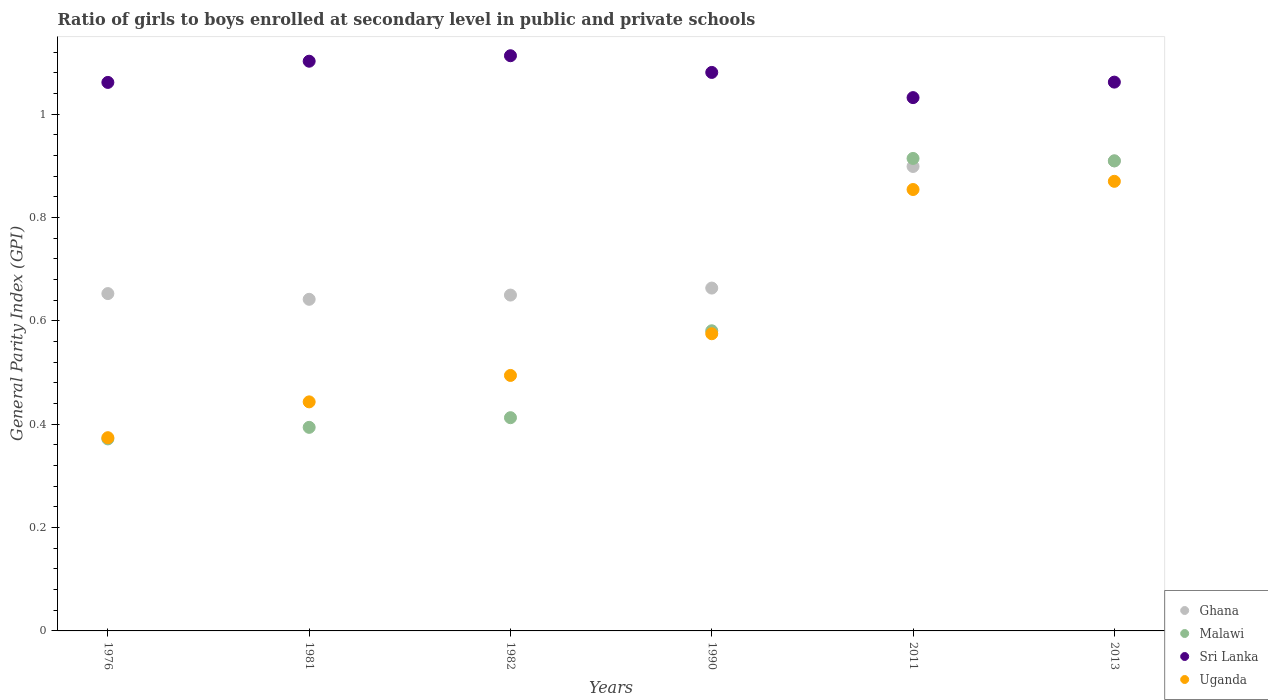How many different coloured dotlines are there?
Offer a terse response. 4. Is the number of dotlines equal to the number of legend labels?
Offer a very short reply. Yes. What is the general parity index in Ghana in 1982?
Provide a succinct answer. 0.65. Across all years, what is the maximum general parity index in Malawi?
Ensure brevity in your answer.  0.91. Across all years, what is the minimum general parity index in Uganda?
Make the answer very short. 0.37. What is the total general parity index in Uganda in the graph?
Your answer should be compact. 3.61. What is the difference between the general parity index in Uganda in 1990 and that in 2013?
Offer a very short reply. -0.3. What is the difference between the general parity index in Malawi in 1981 and the general parity index in Uganda in 1982?
Keep it short and to the point. -0.1. What is the average general parity index in Uganda per year?
Your response must be concise. 0.6. In the year 1982, what is the difference between the general parity index in Sri Lanka and general parity index in Malawi?
Provide a short and direct response. 0.7. What is the ratio of the general parity index in Uganda in 1982 to that in 1990?
Provide a succinct answer. 0.86. Is the difference between the general parity index in Sri Lanka in 1981 and 1990 greater than the difference between the general parity index in Malawi in 1981 and 1990?
Your response must be concise. Yes. What is the difference between the highest and the second highest general parity index in Sri Lanka?
Your answer should be very brief. 0.01. What is the difference between the highest and the lowest general parity index in Ghana?
Ensure brevity in your answer.  0.27. In how many years, is the general parity index in Ghana greater than the average general parity index in Ghana taken over all years?
Ensure brevity in your answer.  2. Is it the case that in every year, the sum of the general parity index in Uganda and general parity index in Ghana  is greater than the sum of general parity index in Malawi and general parity index in Sri Lanka?
Offer a very short reply. Yes. Is the general parity index in Malawi strictly greater than the general parity index in Uganda over the years?
Make the answer very short. No. How many years are there in the graph?
Offer a terse response. 6. Does the graph contain any zero values?
Keep it short and to the point. No. How are the legend labels stacked?
Offer a very short reply. Vertical. What is the title of the graph?
Make the answer very short. Ratio of girls to boys enrolled at secondary level in public and private schools. What is the label or title of the Y-axis?
Offer a very short reply. General Parity Index (GPI). What is the General Parity Index (GPI) of Ghana in 1976?
Your response must be concise. 0.65. What is the General Parity Index (GPI) in Malawi in 1976?
Keep it short and to the point. 0.37. What is the General Parity Index (GPI) of Sri Lanka in 1976?
Offer a terse response. 1.06. What is the General Parity Index (GPI) of Uganda in 1976?
Provide a short and direct response. 0.37. What is the General Parity Index (GPI) in Ghana in 1981?
Your response must be concise. 0.64. What is the General Parity Index (GPI) in Malawi in 1981?
Ensure brevity in your answer.  0.39. What is the General Parity Index (GPI) of Sri Lanka in 1981?
Offer a terse response. 1.1. What is the General Parity Index (GPI) of Uganda in 1981?
Provide a short and direct response. 0.44. What is the General Parity Index (GPI) in Ghana in 1982?
Offer a terse response. 0.65. What is the General Parity Index (GPI) of Malawi in 1982?
Your answer should be very brief. 0.41. What is the General Parity Index (GPI) in Sri Lanka in 1982?
Your answer should be compact. 1.11. What is the General Parity Index (GPI) in Uganda in 1982?
Provide a short and direct response. 0.49. What is the General Parity Index (GPI) of Ghana in 1990?
Provide a short and direct response. 0.66. What is the General Parity Index (GPI) of Malawi in 1990?
Offer a terse response. 0.58. What is the General Parity Index (GPI) of Sri Lanka in 1990?
Your response must be concise. 1.08. What is the General Parity Index (GPI) in Uganda in 1990?
Give a very brief answer. 0.58. What is the General Parity Index (GPI) in Ghana in 2011?
Ensure brevity in your answer.  0.9. What is the General Parity Index (GPI) of Malawi in 2011?
Provide a short and direct response. 0.91. What is the General Parity Index (GPI) in Sri Lanka in 2011?
Ensure brevity in your answer.  1.03. What is the General Parity Index (GPI) of Uganda in 2011?
Your answer should be very brief. 0.85. What is the General Parity Index (GPI) in Ghana in 2013?
Your answer should be compact. 0.91. What is the General Parity Index (GPI) of Malawi in 2013?
Your answer should be compact. 0.91. What is the General Parity Index (GPI) in Sri Lanka in 2013?
Your answer should be compact. 1.06. What is the General Parity Index (GPI) of Uganda in 2013?
Keep it short and to the point. 0.87. Across all years, what is the maximum General Parity Index (GPI) in Ghana?
Offer a terse response. 0.91. Across all years, what is the maximum General Parity Index (GPI) of Malawi?
Your answer should be very brief. 0.91. Across all years, what is the maximum General Parity Index (GPI) in Sri Lanka?
Your answer should be very brief. 1.11. Across all years, what is the maximum General Parity Index (GPI) of Uganda?
Your answer should be very brief. 0.87. Across all years, what is the minimum General Parity Index (GPI) in Ghana?
Provide a short and direct response. 0.64. Across all years, what is the minimum General Parity Index (GPI) of Malawi?
Keep it short and to the point. 0.37. Across all years, what is the minimum General Parity Index (GPI) of Sri Lanka?
Ensure brevity in your answer.  1.03. Across all years, what is the minimum General Parity Index (GPI) in Uganda?
Give a very brief answer. 0.37. What is the total General Parity Index (GPI) in Ghana in the graph?
Your answer should be very brief. 4.42. What is the total General Parity Index (GPI) in Malawi in the graph?
Your answer should be very brief. 3.58. What is the total General Parity Index (GPI) in Sri Lanka in the graph?
Provide a succinct answer. 6.45. What is the total General Parity Index (GPI) in Uganda in the graph?
Your answer should be very brief. 3.61. What is the difference between the General Parity Index (GPI) of Ghana in 1976 and that in 1981?
Your answer should be very brief. 0.01. What is the difference between the General Parity Index (GPI) of Malawi in 1976 and that in 1981?
Provide a short and direct response. -0.02. What is the difference between the General Parity Index (GPI) in Sri Lanka in 1976 and that in 1981?
Offer a very short reply. -0.04. What is the difference between the General Parity Index (GPI) in Uganda in 1976 and that in 1981?
Ensure brevity in your answer.  -0.07. What is the difference between the General Parity Index (GPI) in Ghana in 1976 and that in 1982?
Give a very brief answer. 0. What is the difference between the General Parity Index (GPI) of Malawi in 1976 and that in 1982?
Offer a very short reply. -0.04. What is the difference between the General Parity Index (GPI) in Sri Lanka in 1976 and that in 1982?
Keep it short and to the point. -0.05. What is the difference between the General Parity Index (GPI) of Uganda in 1976 and that in 1982?
Offer a terse response. -0.12. What is the difference between the General Parity Index (GPI) of Ghana in 1976 and that in 1990?
Offer a very short reply. -0.01. What is the difference between the General Parity Index (GPI) of Malawi in 1976 and that in 1990?
Give a very brief answer. -0.21. What is the difference between the General Parity Index (GPI) of Sri Lanka in 1976 and that in 1990?
Provide a short and direct response. -0.02. What is the difference between the General Parity Index (GPI) in Uganda in 1976 and that in 1990?
Your answer should be compact. -0.2. What is the difference between the General Parity Index (GPI) in Ghana in 1976 and that in 2011?
Offer a very short reply. -0.25. What is the difference between the General Parity Index (GPI) of Malawi in 1976 and that in 2011?
Make the answer very short. -0.54. What is the difference between the General Parity Index (GPI) in Sri Lanka in 1976 and that in 2011?
Keep it short and to the point. 0.03. What is the difference between the General Parity Index (GPI) of Uganda in 1976 and that in 2011?
Your response must be concise. -0.48. What is the difference between the General Parity Index (GPI) in Ghana in 1976 and that in 2013?
Provide a succinct answer. -0.26. What is the difference between the General Parity Index (GPI) of Malawi in 1976 and that in 2013?
Make the answer very short. -0.54. What is the difference between the General Parity Index (GPI) in Sri Lanka in 1976 and that in 2013?
Give a very brief answer. -0. What is the difference between the General Parity Index (GPI) of Uganda in 1976 and that in 2013?
Your response must be concise. -0.5. What is the difference between the General Parity Index (GPI) of Ghana in 1981 and that in 1982?
Offer a very short reply. -0.01. What is the difference between the General Parity Index (GPI) of Malawi in 1981 and that in 1982?
Make the answer very short. -0.02. What is the difference between the General Parity Index (GPI) in Sri Lanka in 1981 and that in 1982?
Keep it short and to the point. -0.01. What is the difference between the General Parity Index (GPI) in Uganda in 1981 and that in 1982?
Your answer should be very brief. -0.05. What is the difference between the General Parity Index (GPI) in Ghana in 1981 and that in 1990?
Provide a short and direct response. -0.02. What is the difference between the General Parity Index (GPI) of Malawi in 1981 and that in 1990?
Ensure brevity in your answer.  -0.19. What is the difference between the General Parity Index (GPI) of Sri Lanka in 1981 and that in 1990?
Your response must be concise. 0.02. What is the difference between the General Parity Index (GPI) in Uganda in 1981 and that in 1990?
Offer a terse response. -0.13. What is the difference between the General Parity Index (GPI) in Ghana in 1981 and that in 2011?
Offer a terse response. -0.26. What is the difference between the General Parity Index (GPI) of Malawi in 1981 and that in 2011?
Give a very brief answer. -0.52. What is the difference between the General Parity Index (GPI) of Sri Lanka in 1981 and that in 2011?
Offer a terse response. 0.07. What is the difference between the General Parity Index (GPI) of Uganda in 1981 and that in 2011?
Ensure brevity in your answer.  -0.41. What is the difference between the General Parity Index (GPI) in Ghana in 1981 and that in 2013?
Ensure brevity in your answer.  -0.27. What is the difference between the General Parity Index (GPI) in Malawi in 1981 and that in 2013?
Give a very brief answer. -0.52. What is the difference between the General Parity Index (GPI) of Sri Lanka in 1981 and that in 2013?
Make the answer very short. 0.04. What is the difference between the General Parity Index (GPI) of Uganda in 1981 and that in 2013?
Your response must be concise. -0.43. What is the difference between the General Parity Index (GPI) in Ghana in 1982 and that in 1990?
Offer a terse response. -0.01. What is the difference between the General Parity Index (GPI) in Malawi in 1982 and that in 1990?
Your answer should be compact. -0.17. What is the difference between the General Parity Index (GPI) in Sri Lanka in 1982 and that in 1990?
Offer a very short reply. 0.03. What is the difference between the General Parity Index (GPI) of Uganda in 1982 and that in 1990?
Provide a short and direct response. -0.08. What is the difference between the General Parity Index (GPI) of Ghana in 1982 and that in 2011?
Your response must be concise. -0.25. What is the difference between the General Parity Index (GPI) of Malawi in 1982 and that in 2011?
Ensure brevity in your answer.  -0.5. What is the difference between the General Parity Index (GPI) in Sri Lanka in 1982 and that in 2011?
Make the answer very short. 0.08. What is the difference between the General Parity Index (GPI) in Uganda in 1982 and that in 2011?
Your answer should be compact. -0.36. What is the difference between the General Parity Index (GPI) in Ghana in 1982 and that in 2013?
Your answer should be very brief. -0.26. What is the difference between the General Parity Index (GPI) of Malawi in 1982 and that in 2013?
Offer a terse response. -0.5. What is the difference between the General Parity Index (GPI) of Sri Lanka in 1982 and that in 2013?
Your answer should be compact. 0.05. What is the difference between the General Parity Index (GPI) of Uganda in 1982 and that in 2013?
Your answer should be very brief. -0.38. What is the difference between the General Parity Index (GPI) in Ghana in 1990 and that in 2011?
Your response must be concise. -0.24. What is the difference between the General Parity Index (GPI) in Malawi in 1990 and that in 2011?
Offer a very short reply. -0.33. What is the difference between the General Parity Index (GPI) in Sri Lanka in 1990 and that in 2011?
Provide a succinct answer. 0.05. What is the difference between the General Parity Index (GPI) of Uganda in 1990 and that in 2011?
Offer a terse response. -0.28. What is the difference between the General Parity Index (GPI) of Ghana in 1990 and that in 2013?
Offer a terse response. -0.25. What is the difference between the General Parity Index (GPI) in Malawi in 1990 and that in 2013?
Your answer should be compact. -0.33. What is the difference between the General Parity Index (GPI) of Sri Lanka in 1990 and that in 2013?
Keep it short and to the point. 0.02. What is the difference between the General Parity Index (GPI) of Uganda in 1990 and that in 2013?
Ensure brevity in your answer.  -0.29. What is the difference between the General Parity Index (GPI) in Ghana in 2011 and that in 2013?
Provide a succinct answer. -0.01. What is the difference between the General Parity Index (GPI) in Malawi in 2011 and that in 2013?
Your answer should be very brief. 0. What is the difference between the General Parity Index (GPI) of Sri Lanka in 2011 and that in 2013?
Offer a terse response. -0.03. What is the difference between the General Parity Index (GPI) of Uganda in 2011 and that in 2013?
Provide a short and direct response. -0.02. What is the difference between the General Parity Index (GPI) in Ghana in 1976 and the General Parity Index (GPI) in Malawi in 1981?
Provide a succinct answer. 0.26. What is the difference between the General Parity Index (GPI) in Ghana in 1976 and the General Parity Index (GPI) in Sri Lanka in 1981?
Your response must be concise. -0.45. What is the difference between the General Parity Index (GPI) of Ghana in 1976 and the General Parity Index (GPI) of Uganda in 1981?
Give a very brief answer. 0.21. What is the difference between the General Parity Index (GPI) in Malawi in 1976 and the General Parity Index (GPI) in Sri Lanka in 1981?
Your answer should be very brief. -0.73. What is the difference between the General Parity Index (GPI) in Malawi in 1976 and the General Parity Index (GPI) in Uganda in 1981?
Your answer should be very brief. -0.07. What is the difference between the General Parity Index (GPI) of Sri Lanka in 1976 and the General Parity Index (GPI) of Uganda in 1981?
Your answer should be compact. 0.62. What is the difference between the General Parity Index (GPI) in Ghana in 1976 and the General Parity Index (GPI) in Malawi in 1982?
Offer a terse response. 0.24. What is the difference between the General Parity Index (GPI) of Ghana in 1976 and the General Parity Index (GPI) of Sri Lanka in 1982?
Make the answer very short. -0.46. What is the difference between the General Parity Index (GPI) of Ghana in 1976 and the General Parity Index (GPI) of Uganda in 1982?
Provide a short and direct response. 0.16. What is the difference between the General Parity Index (GPI) of Malawi in 1976 and the General Parity Index (GPI) of Sri Lanka in 1982?
Your answer should be compact. -0.74. What is the difference between the General Parity Index (GPI) in Malawi in 1976 and the General Parity Index (GPI) in Uganda in 1982?
Your response must be concise. -0.12. What is the difference between the General Parity Index (GPI) of Sri Lanka in 1976 and the General Parity Index (GPI) of Uganda in 1982?
Your answer should be very brief. 0.57. What is the difference between the General Parity Index (GPI) of Ghana in 1976 and the General Parity Index (GPI) of Malawi in 1990?
Keep it short and to the point. 0.07. What is the difference between the General Parity Index (GPI) of Ghana in 1976 and the General Parity Index (GPI) of Sri Lanka in 1990?
Give a very brief answer. -0.43. What is the difference between the General Parity Index (GPI) in Ghana in 1976 and the General Parity Index (GPI) in Uganda in 1990?
Provide a succinct answer. 0.08. What is the difference between the General Parity Index (GPI) in Malawi in 1976 and the General Parity Index (GPI) in Sri Lanka in 1990?
Keep it short and to the point. -0.71. What is the difference between the General Parity Index (GPI) in Malawi in 1976 and the General Parity Index (GPI) in Uganda in 1990?
Your response must be concise. -0.2. What is the difference between the General Parity Index (GPI) of Sri Lanka in 1976 and the General Parity Index (GPI) of Uganda in 1990?
Make the answer very short. 0.49. What is the difference between the General Parity Index (GPI) in Ghana in 1976 and the General Parity Index (GPI) in Malawi in 2011?
Make the answer very short. -0.26. What is the difference between the General Parity Index (GPI) in Ghana in 1976 and the General Parity Index (GPI) in Sri Lanka in 2011?
Offer a terse response. -0.38. What is the difference between the General Parity Index (GPI) of Ghana in 1976 and the General Parity Index (GPI) of Uganda in 2011?
Keep it short and to the point. -0.2. What is the difference between the General Parity Index (GPI) of Malawi in 1976 and the General Parity Index (GPI) of Sri Lanka in 2011?
Your answer should be very brief. -0.66. What is the difference between the General Parity Index (GPI) in Malawi in 1976 and the General Parity Index (GPI) in Uganda in 2011?
Your answer should be very brief. -0.48. What is the difference between the General Parity Index (GPI) in Sri Lanka in 1976 and the General Parity Index (GPI) in Uganda in 2011?
Provide a short and direct response. 0.21. What is the difference between the General Parity Index (GPI) in Ghana in 1976 and the General Parity Index (GPI) in Malawi in 2013?
Offer a terse response. -0.26. What is the difference between the General Parity Index (GPI) of Ghana in 1976 and the General Parity Index (GPI) of Sri Lanka in 2013?
Ensure brevity in your answer.  -0.41. What is the difference between the General Parity Index (GPI) of Ghana in 1976 and the General Parity Index (GPI) of Uganda in 2013?
Give a very brief answer. -0.22. What is the difference between the General Parity Index (GPI) in Malawi in 1976 and the General Parity Index (GPI) in Sri Lanka in 2013?
Provide a succinct answer. -0.69. What is the difference between the General Parity Index (GPI) of Malawi in 1976 and the General Parity Index (GPI) of Uganda in 2013?
Your response must be concise. -0.5. What is the difference between the General Parity Index (GPI) in Sri Lanka in 1976 and the General Parity Index (GPI) in Uganda in 2013?
Offer a very short reply. 0.19. What is the difference between the General Parity Index (GPI) of Ghana in 1981 and the General Parity Index (GPI) of Malawi in 1982?
Make the answer very short. 0.23. What is the difference between the General Parity Index (GPI) in Ghana in 1981 and the General Parity Index (GPI) in Sri Lanka in 1982?
Make the answer very short. -0.47. What is the difference between the General Parity Index (GPI) in Ghana in 1981 and the General Parity Index (GPI) in Uganda in 1982?
Offer a terse response. 0.15. What is the difference between the General Parity Index (GPI) in Malawi in 1981 and the General Parity Index (GPI) in Sri Lanka in 1982?
Provide a short and direct response. -0.72. What is the difference between the General Parity Index (GPI) of Malawi in 1981 and the General Parity Index (GPI) of Uganda in 1982?
Your answer should be compact. -0.1. What is the difference between the General Parity Index (GPI) of Sri Lanka in 1981 and the General Parity Index (GPI) of Uganda in 1982?
Make the answer very short. 0.61. What is the difference between the General Parity Index (GPI) in Ghana in 1981 and the General Parity Index (GPI) in Malawi in 1990?
Keep it short and to the point. 0.06. What is the difference between the General Parity Index (GPI) in Ghana in 1981 and the General Parity Index (GPI) in Sri Lanka in 1990?
Ensure brevity in your answer.  -0.44. What is the difference between the General Parity Index (GPI) in Ghana in 1981 and the General Parity Index (GPI) in Uganda in 1990?
Provide a short and direct response. 0.07. What is the difference between the General Parity Index (GPI) of Malawi in 1981 and the General Parity Index (GPI) of Sri Lanka in 1990?
Your answer should be very brief. -0.69. What is the difference between the General Parity Index (GPI) in Malawi in 1981 and the General Parity Index (GPI) in Uganda in 1990?
Give a very brief answer. -0.18. What is the difference between the General Parity Index (GPI) in Sri Lanka in 1981 and the General Parity Index (GPI) in Uganda in 1990?
Your response must be concise. 0.53. What is the difference between the General Parity Index (GPI) of Ghana in 1981 and the General Parity Index (GPI) of Malawi in 2011?
Your answer should be very brief. -0.27. What is the difference between the General Parity Index (GPI) of Ghana in 1981 and the General Parity Index (GPI) of Sri Lanka in 2011?
Offer a very short reply. -0.39. What is the difference between the General Parity Index (GPI) in Ghana in 1981 and the General Parity Index (GPI) in Uganda in 2011?
Keep it short and to the point. -0.21. What is the difference between the General Parity Index (GPI) of Malawi in 1981 and the General Parity Index (GPI) of Sri Lanka in 2011?
Ensure brevity in your answer.  -0.64. What is the difference between the General Parity Index (GPI) in Malawi in 1981 and the General Parity Index (GPI) in Uganda in 2011?
Give a very brief answer. -0.46. What is the difference between the General Parity Index (GPI) in Sri Lanka in 1981 and the General Parity Index (GPI) in Uganda in 2011?
Give a very brief answer. 0.25. What is the difference between the General Parity Index (GPI) in Ghana in 1981 and the General Parity Index (GPI) in Malawi in 2013?
Make the answer very short. -0.27. What is the difference between the General Parity Index (GPI) of Ghana in 1981 and the General Parity Index (GPI) of Sri Lanka in 2013?
Your answer should be very brief. -0.42. What is the difference between the General Parity Index (GPI) in Ghana in 1981 and the General Parity Index (GPI) in Uganda in 2013?
Your answer should be very brief. -0.23. What is the difference between the General Parity Index (GPI) in Malawi in 1981 and the General Parity Index (GPI) in Sri Lanka in 2013?
Give a very brief answer. -0.67. What is the difference between the General Parity Index (GPI) of Malawi in 1981 and the General Parity Index (GPI) of Uganda in 2013?
Provide a succinct answer. -0.48. What is the difference between the General Parity Index (GPI) of Sri Lanka in 1981 and the General Parity Index (GPI) of Uganda in 2013?
Make the answer very short. 0.23. What is the difference between the General Parity Index (GPI) of Ghana in 1982 and the General Parity Index (GPI) of Malawi in 1990?
Give a very brief answer. 0.07. What is the difference between the General Parity Index (GPI) of Ghana in 1982 and the General Parity Index (GPI) of Sri Lanka in 1990?
Your answer should be compact. -0.43. What is the difference between the General Parity Index (GPI) in Ghana in 1982 and the General Parity Index (GPI) in Uganda in 1990?
Make the answer very short. 0.07. What is the difference between the General Parity Index (GPI) of Malawi in 1982 and the General Parity Index (GPI) of Sri Lanka in 1990?
Provide a succinct answer. -0.67. What is the difference between the General Parity Index (GPI) of Malawi in 1982 and the General Parity Index (GPI) of Uganda in 1990?
Make the answer very short. -0.16. What is the difference between the General Parity Index (GPI) of Sri Lanka in 1982 and the General Parity Index (GPI) of Uganda in 1990?
Your response must be concise. 0.54. What is the difference between the General Parity Index (GPI) in Ghana in 1982 and the General Parity Index (GPI) in Malawi in 2011?
Your response must be concise. -0.26. What is the difference between the General Parity Index (GPI) of Ghana in 1982 and the General Parity Index (GPI) of Sri Lanka in 2011?
Your answer should be very brief. -0.38. What is the difference between the General Parity Index (GPI) of Ghana in 1982 and the General Parity Index (GPI) of Uganda in 2011?
Your response must be concise. -0.2. What is the difference between the General Parity Index (GPI) of Malawi in 1982 and the General Parity Index (GPI) of Sri Lanka in 2011?
Your response must be concise. -0.62. What is the difference between the General Parity Index (GPI) in Malawi in 1982 and the General Parity Index (GPI) in Uganda in 2011?
Give a very brief answer. -0.44. What is the difference between the General Parity Index (GPI) of Sri Lanka in 1982 and the General Parity Index (GPI) of Uganda in 2011?
Give a very brief answer. 0.26. What is the difference between the General Parity Index (GPI) in Ghana in 1982 and the General Parity Index (GPI) in Malawi in 2013?
Make the answer very short. -0.26. What is the difference between the General Parity Index (GPI) of Ghana in 1982 and the General Parity Index (GPI) of Sri Lanka in 2013?
Provide a succinct answer. -0.41. What is the difference between the General Parity Index (GPI) in Ghana in 1982 and the General Parity Index (GPI) in Uganda in 2013?
Offer a terse response. -0.22. What is the difference between the General Parity Index (GPI) in Malawi in 1982 and the General Parity Index (GPI) in Sri Lanka in 2013?
Give a very brief answer. -0.65. What is the difference between the General Parity Index (GPI) of Malawi in 1982 and the General Parity Index (GPI) of Uganda in 2013?
Give a very brief answer. -0.46. What is the difference between the General Parity Index (GPI) in Sri Lanka in 1982 and the General Parity Index (GPI) in Uganda in 2013?
Make the answer very short. 0.24. What is the difference between the General Parity Index (GPI) of Ghana in 1990 and the General Parity Index (GPI) of Malawi in 2011?
Your response must be concise. -0.25. What is the difference between the General Parity Index (GPI) in Ghana in 1990 and the General Parity Index (GPI) in Sri Lanka in 2011?
Your answer should be very brief. -0.37. What is the difference between the General Parity Index (GPI) of Ghana in 1990 and the General Parity Index (GPI) of Uganda in 2011?
Your answer should be very brief. -0.19. What is the difference between the General Parity Index (GPI) of Malawi in 1990 and the General Parity Index (GPI) of Sri Lanka in 2011?
Make the answer very short. -0.45. What is the difference between the General Parity Index (GPI) of Malawi in 1990 and the General Parity Index (GPI) of Uganda in 2011?
Make the answer very short. -0.27. What is the difference between the General Parity Index (GPI) of Sri Lanka in 1990 and the General Parity Index (GPI) of Uganda in 2011?
Your answer should be compact. 0.23. What is the difference between the General Parity Index (GPI) in Ghana in 1990 and the General Parity Index (GPI) in Malawi in 2013?
Provide a succinct answer. -0.25. What is the difference between the General Parity Index (GPI) in Ghana in 1990 and the General Parity Index (GPI) in Sri Lanka in 2013?
Your answer should be compact. -0.4. What is the difference between the General Parity Index (GPI) in Ghana in 1990 and the General Parity Index (GPI) in Uganda in 2013?
Ensure brevity in your answer.  -0.21. What is the difference between the General Parity Index (GPI) of Malawi in 1990 and the General Parity Index (GPI) of Sri Lanka in 2013?
Ensure brevity in your answer.  -0.48. What is the difference between the General Parity Index (GPI) of Malawi in 1990 and the General Parity Index (GPI) of Uganda in 2013?
Make the answer very short. -0.29. What is the difference between the General Parity Index (GPI) of Sri Lanka in 1990 and the General Parity Index (GPI) of Uganda in 2013?
Your answer should be compact. 0.21. What is the difference between the General Parity Index (GPI) in Ghana in 2011 and the General Parity Index (GPI) in Malawi in 2013?
Your answer should be very brief. -0.01. What is the difference between the General Parity Index (GPI) in Ghana in 2011 and the General Parity Index (GPI) in Sri Lanka in 2013?
Provide a succinct answer. -0.16. What is the difference between the General Parity Index (GPI) of Ghana in 2011 and the General Parity Index (GPI) of Uganda in 2013?
Give a very brief answer. 0.03. What is the difference between the General Parity Index (GPI) in Malawi in 2011 and the General Parity Index (GPI) in Sri Lanka in 2013?
Offer a terse response. -0.15. What is the difference between the General Parity Index (GPI) in Malawi in 2011 and the General Parity Index (GPI) in Uganda in 2013?
Your response must be concise. 0.04. What is the difference between the General Parity Index (GPI) in Sri Lanka in 2011 and the General Parity Index (GPI) in Uganda in 2013?
Your answer should be compact. 0.16. What is the average General Parity Index (GPI) of Ghana per year?
Offer a terse response. 0.74. What is the average General Parity Index (GPI) of Malawi per year?
Your answer should be very brief. 0.6. What is the average General Parity Index (GPI) in Sri Lanka per year?
Offer a terse response. 1.08. What is the average General Parity Index (GPI) in Uganda per year?
Offer a very short reply. 0.6. In the year 1976, what is the difference between the General Parity Index (GPI) of Ghana and General Parity Index (GPI) of Malawi?
Provide a short and direct response. 0.28. In the year 1976, what is the difference between the General Parity Index (GPI) in Ghana and General Parity Index (GPI) in Sri Lanka?
Provide a short and direct response. -0.41. In the year 1976, what is the difference between the General Parity Index (GPI) in Ghana and General Parity Index (GPI) in Uganda?
Your response must be concise. 0.28. In the year 1976, what is the difference between the General Parity Index (GPI) in Malawi and General Parity Index (GPI) in Sri Lanka?
Offer a very short reply. -0.69. In the year 1976, what is the difference between the General Parity Index (GPI) in Malawi and General Parity Index (GPI) in Uganda?
Offer a very short reply. -0. In the year 1976, what is the difference between the General Parity Index (GPI) of Sri Lanka and General Parity Index (GPI) of Uganda?
Ensure brevity in your answer.  0.69. In the year 1981, what is the difference between the General Parity Index (GPI) of Ghana and General Parity Index (GPI) of Malawi?
Make the answer very short. 0.25. In the year 1981, what is the difference between the General Parity Index (GPI) of Ghana and General Parity Index (GPI) of Sri Lanka?
Provide a short and direct response. -0.46. In the year 1981, what is the difference between the General Parity Index (GPI) in Ghana and General Parity Index (GPI) in Uganda?
Offer a terse response. 0.2. In the year 1981, what is the difference between the General Parity Index (GPI) of Malawi and General Parity Index (GPI) of Sri Lanka?
Ensure brevity in your answer.  -0.71. In the year 1981, what is the difference between the General Parity Index (GPI) of Malawi and General Parity Index (GPI) of Uganda?
Your answer should be very brief. -0.05. In the year 1981, what is the difference between the General Parity Index (GPI) in Sri Lanka and General Parity Index (GPI) in Uganda?
Offer a very short reply. 0.66. In the year 1982, what is the difference between the General Parity Index (GPI) in Ghana and General Parity Index (GPI) in Malawi?
Keep it short and to the point. 0.24. In the year 1982, what is the difference between the General Parity Index (GPI) in Ghana and General Parity Index (GPI) in Sri Lanka?
Provide a short and direct response. -0.46. In the year 1982, what is the difference between the General Parity Index (GPI) in Ghana and General Parity Index (GPI) in Uganda?
Offer a terse response. 0.16. In the year 1982, what is the difference between the General Parity Index (GPI) in Malawi and General Parity Index (GPI) in Sri Lanka?
Make the answer very short. -0.7. In the year 1982, what is the difference between the General Parity Index (GPI) of Malawi and General Parity Index (GPI) of Uganda?
Give a very brief answer. -0.08. In the year 1982, what is the difference between the General Parity Index (GPI) of Sri Lanka and General Parity Index (GPI) of Uganda?
Offer a very short reply. 0.62. In the year 1990, what is the difference between the General Parity Index (GPI) of Ghana and General Parity Index (GPI) of Malawi?
Provide a short and direct response. 0.08. In the year 1990, what is the difference between the General Parity Index (GPI) of Ghana and General Parity Index (GPI) of Sri Lanka?
Ensure brevity in your answer.  -0.42. In the year 1990, what is the difference between the General Parity Index (GPI) in Ghana and General Parity Index (GPI) in Uganda?
Ensure brevity in your answer.  0.09. In the year 1990, what is the difference between the General Parity Index (GPI) of Malawi and General Parity Index (GPI) of Uganda?
Give a very brief answer. 0.01. In the year 1990, what is the difference between the General Parity Index (GPI) in Sri Lanka and General Parity Index (GPI) in Uganda?
Give a very brief answer. 0.51. In the year 2011, what is the difference between the General Parity Index (GPI) in Ghana and General Parity Index (GPI) in Malawi?
Offer a very short reply. -0.02. In the year 2011, what is the difference between the General Parity Index (GPI) in Ghana and General Parity Index (GPI) in Sri Lanka?
Offer a terse response. -0.13. In the year 2011, what is the difference between the General Parity Index (GPI) of Ghana and General Parity Index (GPI) of Uganda?
Keep it short and to the point. 0.04. In the year 2011, what is the difference between the General Parity Index (GPI) of Malawi and General Parity Index (GPI) of Sri Lanka?
Keep it short and to the point. -0.12. In the year 2011, what is the difference between the General Parity Index (GPI) of Malawi and General Parity Index (GPI) of Uganda?
Your response must be concise. 0.06. In the year 2011, what is the difference between the General Parity Index (GPI) in Sri Lanka and General Parity Index (GPI) in Uganda?
Offer a terse response. 0.18. In the year 2013, what is the difference between the General Parity Index (GPI) of Ghana and General Parity Index (GPI) of Sri Lanka?
Your response must be concise. -0.15. In the year 2013, what is the difference between the General Parity Index (GPI) in Ghana and General Parity Index (GPI) in Uganda?
Your answer should be very brief. 0.04. In the year 2013, what is the difference between the General Parity Index (GPI) of Malawi and General Parity Index (GPI) of Sri Lanka?
Ensure brevity in your answer.  -0.15. In the year 2013, what is the difference between the General Parity Index (GPI) of Malawi and General Parity Index (GPI) of Uganda?
Provide a succinct answer. 0.04. In the year 2013, what is the difference between the General Parity Index (GPI) in Sri Lanka and General Parity Index (GPI) in Uganda?
Provide a succinct answer. 0.19. What is the ratio of the General Parity Index (GPI) of Ghana in 1976 to that in 1981?
Offer a terse response. 1.02. What is the ratio of the General Parity Index (GPI) of Malawi in 1976 to that in 1981?
Give a very brief answer. 0.94. What is the ratio of the General Parity Index (GPI) in Sri Lanka in 1976 to that in 1981?
Offer a terse response. 0.96. What is the ratio of the General Parity Index (GPI) of Uganda in 1976 to that in 1981?
Offer a very short reply. 0.84. What is the ratio of the General Parity Index (GPI) of Ghana in 1976 to that in 1982?
Offer a terse response. 1. What is the ratio of the General Parity Index (GPI) in Malawi in 1976 to that in 1982?
Give a very brief answer. 0.9. What is the ratio of the General Parity Index (GPI) in Sri Lanka in 1976 to that in 1982?
Ensure brevity in your answer.  0.95. What is the ratio of the General Parity Index (GPI) of Uganda in 1976 to that in 1982?
Offer a very short reply. 0.76. What is the ratio of the General Parity Index (GPI) of Ghana in 1976 to that in 1990?
Your response must be concise. 0.98. What is the ratio of the General Parity Index (GPI) in Malawi in 1976 to that in 1990?
Make the answer very short. 0.64. What is the ratio of the General Parity Index (GPI) in Sri Lanka in 1976 to that in 1990?
Your response must be concise. 0.98. What is the ratio of the General Parity Index (GPI) of Uganda in 1976 to that in 1990?
Make the answer very short. 0.65. What is the ratio of the General Parity Index (GPI) of Ghana in 1976 to that in 2011?
Provide a short and direct response. 0.73. What is the ratio of the General Parity Index (GPI) in Malawi in 1976 to that in 2011?
Your answer should be compact. 0.41. What is the ratio of the General Parity Index (GPI) in Sri Lanka in 1976 to that in 2011?
Your answer should be compact. 1.03. What is the ratio of the General Parity Index (GPI) in Uganda in 1976 to that in 2011?
Give a very brief answer. 0.44. What is the ratio of the General Parity Index (GPI) of Ghana in 1976 to that in 2013?
Your answer should be compact. 0.72. What is the ratio of the General Parity Index (GPI) of Malawi in 1976 to that in 2013?
Your response must be concise. 0.41. What is the ratio of the General Parity Index (GPI) in Uganda in 1976 to that in 2013?
Your response must be concise. 0.43. What is the ratio of the General Parity Index (GPI) of Ghana in 1981 to that in 1982?
Ensure brevity in your answer.  0.99. What is the ratio of the General Parity Index (GPI) of Malawi in 1981 to that in 1982?
Give a very brief answer. 0.95. What is the ratio of the General Parity Index (GPI) in Sri Lanka in 1981 to that in 1982?
Offer a very short reply. 0.99. What is the ratio of the General Parity Index (GPI) in Uganda in 1981 to that in 1982?
Provide a succinct answer. 0.9. What is the ratio of the General Parity Index (GPI) in Ghana in 1981 to that in 1990?
Make the answer very short. 0.97. What is the ratio of the General Parity Index (GPI) in Malawi in 1981 to that in 1990?
Provide a short and direct response. 0.68. What is the ratio of the General Parity Index (GPI) in Sri Lanka in 1981 to that in 1990?
Provide a short and direct response. 1.02. What is the ratio of the General Parity Index (GPI) of Uganda in 1981 to that in 1990?
Keep it short and to the point. 0.77. What is the ratio of the General Parity Index (GPI) in Ghana in 1981 to that in 2011?
Give a very brief answer. 0.71. What is the ratio of the General Parity Index (GPI) in Malawi in 1981 to that in 2011?
Provide a short and direct response. 0.43. What is the ratio of the General Parity Index (GPI) of Sri Lanka in 1981 to that in 2011?
Your response must be concise. 1.07. What is the ratio of the General Parity Index (GPI) of Uganda in 1981 to that in 2011?
Ensure brevity in your answer.  0.52. What is the ratio of the General Parity Index (GPI) of Ghana in 1981 to that in 2013?
Offer a very short reply. 0.71. What is the ratio of the General Parity Index (GPI) in Malawi in 1981 to that in 2013?
Make the answer very short. 0.43. What is the ratio of the General Parity Index (GPI) in Sri Lanka in 1981 to that in 2013?
Your answer should be compact. 1.04. What is the ratio of the General Parity Index (GPI) in Uganda in 1981 to that in 2013?
Your answer should be very brief. 0.51. What is the ratio of the General Parity Index (GPI) in Ghana in 1982 to that in 1990?
Keep it short and to the point. 0.98. What is the ratio of the General Parity Index (GPI) of Malawi in 1982 to that in 1990?
Make the answer very short. 0.71. What is the ratio of the General Parity Index (GPI) of Sri Lanka in 1982 to that in 1990?
Your answer should be compact. 1.03. What is the ratio of the General Parity Index (GPI) of Uganda in 1982 to that in 1990?
Your response must be concise. 0.86. What is the ratio of the General Parity Index (GPI) in Ghana in 1982 to that in 2011?
Make the answer very short. 0.72. What is the ratio of the General Parity Index (GPI) of Malawi in 1982 to that in 2011?
Your response must be concise. 0.45. What is the ratio of the General Parity Index (GPI) in Sri Lanka in 1982 to that in 2011?
Make the answer very short. 1.08. What is the ratio of the General Parity Index (GPI) of Uganda in 1982 to that in 2011?
Keep it short and to the point. 0.58. What is the ratio of the General Parity Index (GPI) of Ghana in 1982 to that in 2013?
Give a very brief answer. 0.71. What is the ratio of the General Parity Index (GPI) of Malawi in 1982 to that in 2013?
Your response must be concise. 0.45. What is the ratio of the General Parity Index (GPI) in Sri Lanka in 1982 to that in 2013?
Your response must be concise. 1.05. What is the ratio of the General Parity Index (GPI) of Uganda in 1982 to that in 2013?
Give a very brief answer. 0.57. What is the ratio of the General Parity Index (GPI) of Ghana in 1990 to that in 2011?
Give a very brief answer. 0.74. What is the ratio of the General Parity Index (GPI) of Malawi in 1990 to that in 2011?
Give a very brief answer. 0.64. What is the ratio of the General Parity Index (GPI) in Sri Lanka in 1990 to that in 2011?
Make the answer very short. 1.05. What is the ratio of the General Parity Index (GPI) of Uganda in 1990 to that in 2011?
Provide a short and direct response. 0.67. What is the ratio of the General Parity Index (GPI) in Ghana in 1990 to that in 2013?
Your answer should be very brief. 0.73. What is the ratio of the General Parity Index (GPI) in Malawi in 1990 to that in 2013?
Provide a short and direct response. 0.64. What is the ratio of the General Parity Index (GPI) in Sri Lanka in 1990 to that in 2013?
Provide a short and direct response. 1.02. What is the ratio of the General Parity Index (GPI) in Uganda in 1990 to that in 2013?
Provide a short and direct response. 0.66. What is the ratio of the General Parity Index (GPI) of Ghana in 2011 to that in 2013?
Your response must be concise. 0.99. What is the ratio of the General Parity Index (GPI) of Malawi in 2011 to that in 2013?
Your answer should be very brief. 1.01. What is the ratio of the General Parity Index (GPI) in Sri Lanka in 2011 to that in 2013?
Your answer should be very brief. 0.97. What is the ratio of the General Parity Index (GPI) of Uganda in 2011 to that in 2013?
Your answer should be very brief. 0.98. What is the difference between the highest and the second highest General Parity Index (GPI) in Ghana?
Give a very brief answer. 0.01. What is the difference between the highest and the second highest General Parity Index (GPI) of Malawi?
Keep it short and to the point. 0. What is the difference between the highest and the second highest General Parity Index (GPI) of Sri Lanka?
Ensure brevity in your answer.  0.01. What is the difference between the highest and the second highest General Parity Index (GPI) in Uganda?
Provide a succinct answer. 0.02. What is the difference between the highest and the lowest General Parity Index (GPI) of Ghana?
Your answer should be compact. 0.27. What is the difference between the highest and the lowest General Parity Index (GPI) in Malawi?
Your answer should be compact. 0.54. What is the difference between the highest and the lowest General Parity Index (GPI) of Sri Lanka?
Offer a very short reply. 0.08. What is the difference between the highest and the lowest General Parity Index (GPI) of Uganda?
Your answer should be very brief. 0.5. 